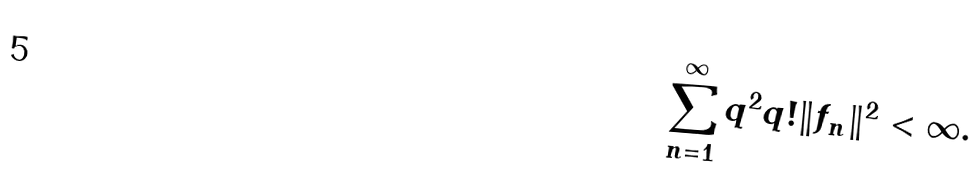Convert formula to latex. <formula><loc_0><loc_0><loc_500><loc_500>\sum _ { n = 1 } ^ { \infty } q ^ { 2 } q ! \| f _ { n } \| ^ { 2 } < \infty .</formula> 